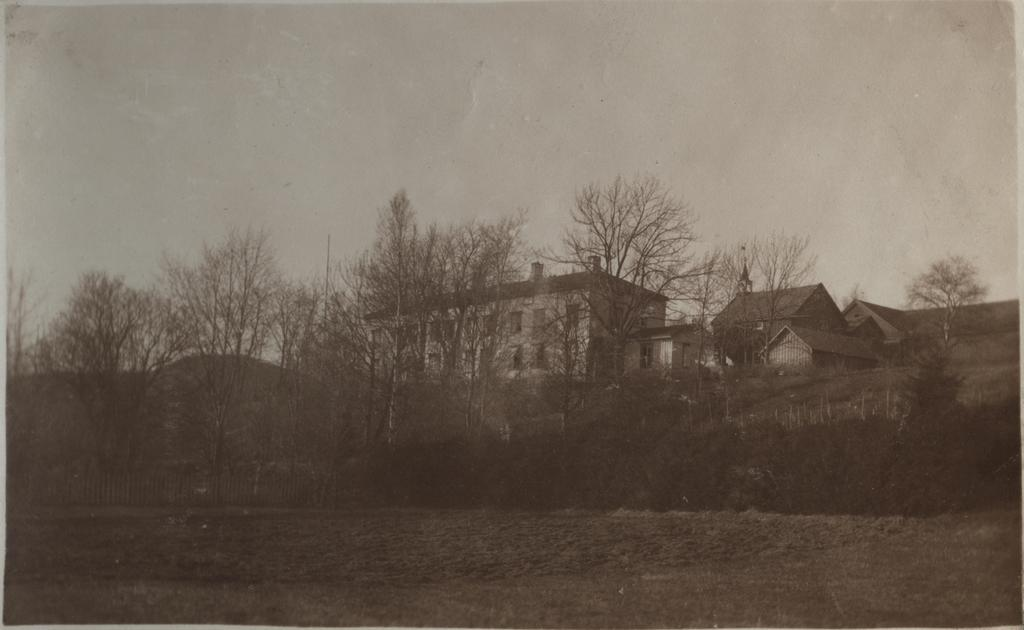What type of natural elements can be seen in the image? There are trees in the image. What type of man-made structures are visible in the background? There are buildings in the background of the image. What part of the natural environment is visible in the image? The sky is visible at the top of the image. What is the color scheme of the image? The image is black and white. Can you tell me how many chances the ear has to fall out of the crib in the image? There is no ear or crib present in the image, so this question cannot be answered. 